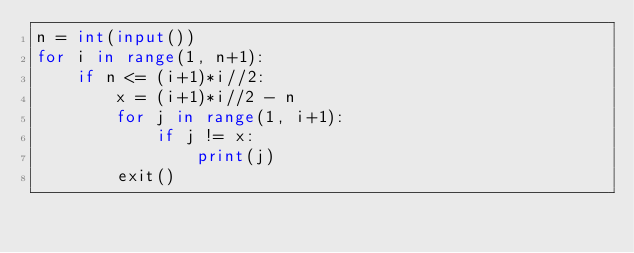<code> <loc_0><loc_0><loc_500><loc_500><_Python_>n = int(input())
for i in range(1, n+1):
    if n <= (i+1)*i//2:
        x = (i+1)*i//2 - n
        for j in range(1, i+1):
            if j != x:
                print(j)
        exit()</code> 